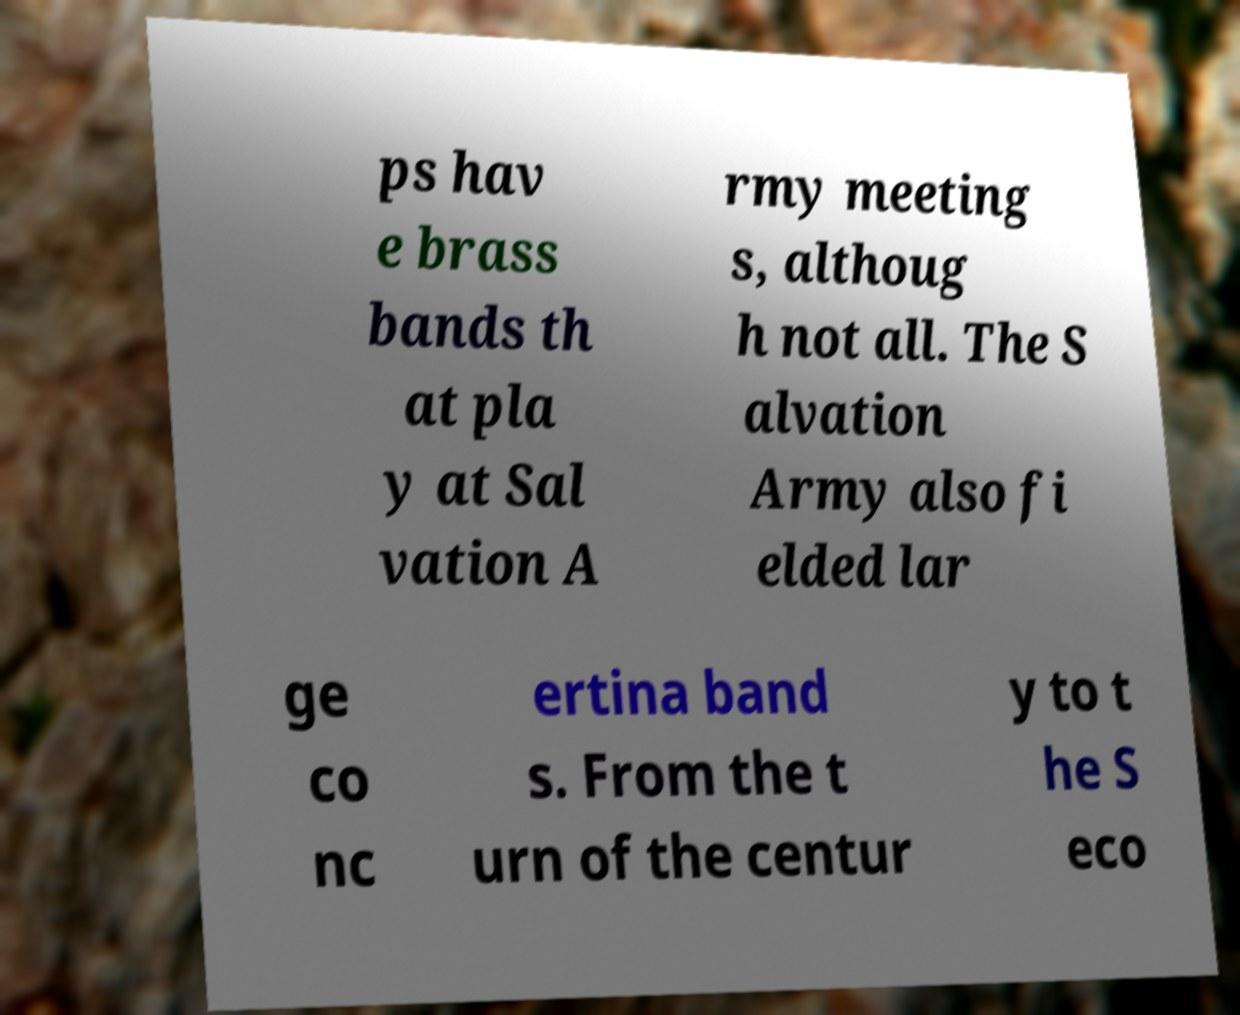For documentation purposes, I need the text within this image transcribed. Could you provide that? ps hav e brass bands th at pla y at Sal vation A rmy meeting s, althoug h not all. The S alvation Army also fi elded lar ge co nc ertina band s. From the t urn of the centur y to t he S eco 